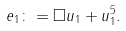<formula> <loc_0><loc_0><loc_500><loc_500>e _ { 1 } \colon = \Box u _ { 1 } + u _ { 1 } ^ { 5 } .</formula> 